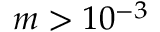<formula> <loc_0><loc_0><loc_500><loc_500>m > 1 0 ^ { - 3 }</formula> 